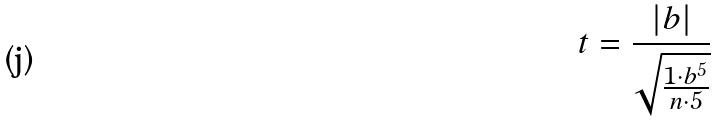Convert formula to latex. <formula><loc_0><loc_0><loc_500><loc_500>t = \frac { | b | } { \sqrt { \frac { 1 \cdot b ^ { 5 } } { n \cdot 5 } } }</formula> 